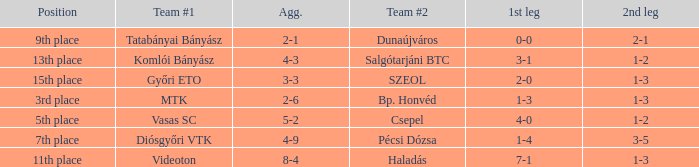What is the 2nd leg of the 4-9 agg.? 3-5. 